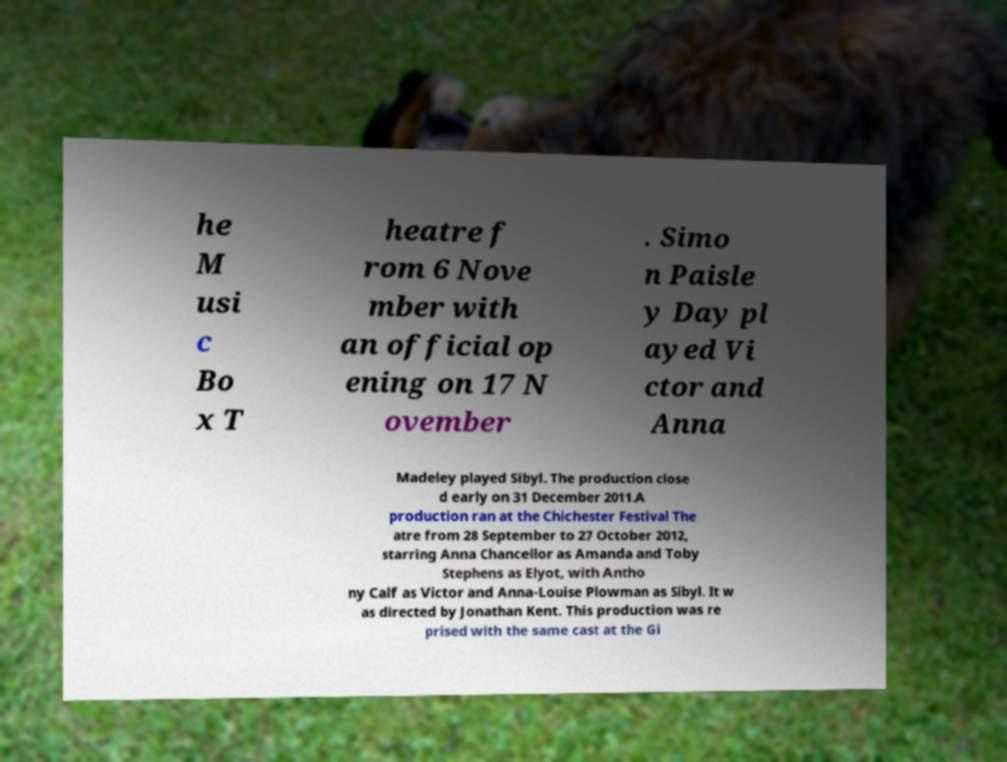What messages or text are displayed in this image? I need them in a readable, typed format. he M usi c Bo x T heatre f rom 6 Nove mber with an official op ening on 17 N ovember . Simo n Paisle y Day pl ayed Vi ctor and Anna Madeley played Sibyl. The production close d early on 31 December 2011.A production ran at the Chichester Festival The atre from 28 September to 27 October 2012, starring Anna Chancellor as Amanda and Toby Stephens as Elyot, with Antho ny Calf as Victor and Anna-Louise Plowman as Sibyl. It w as directed by Jonathan Kent. This production was re prised with the same cast at the Gi 